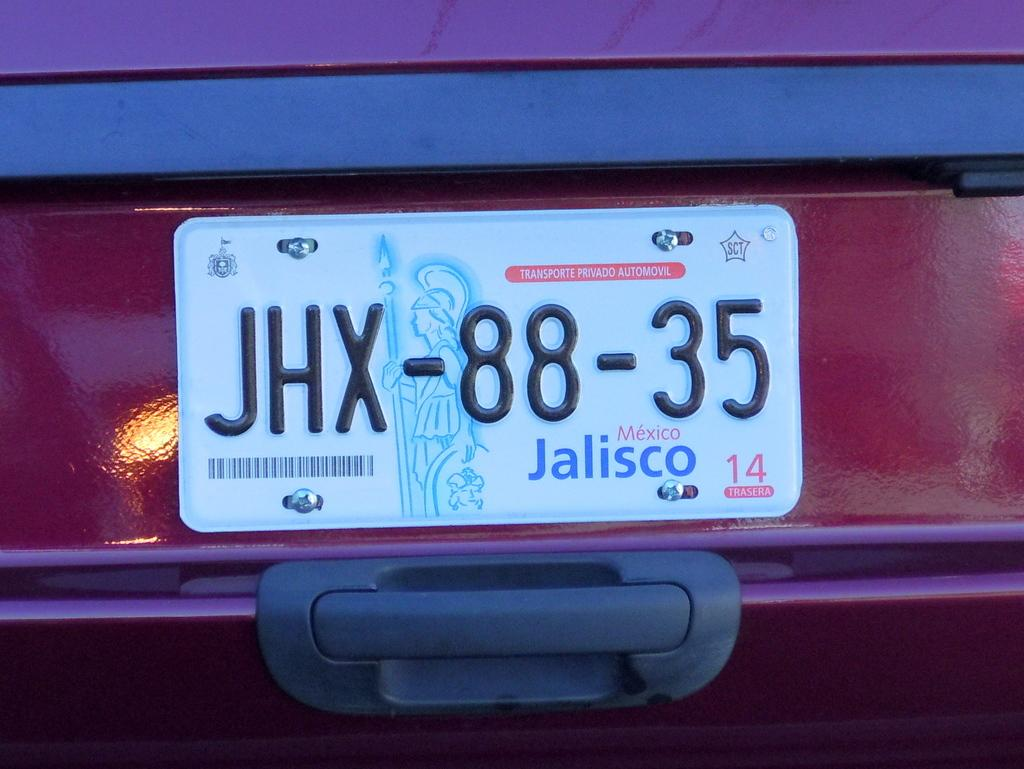<image>
Present a compact description of the photo's key features. A car plate from the city of Jalisco, Mexico 